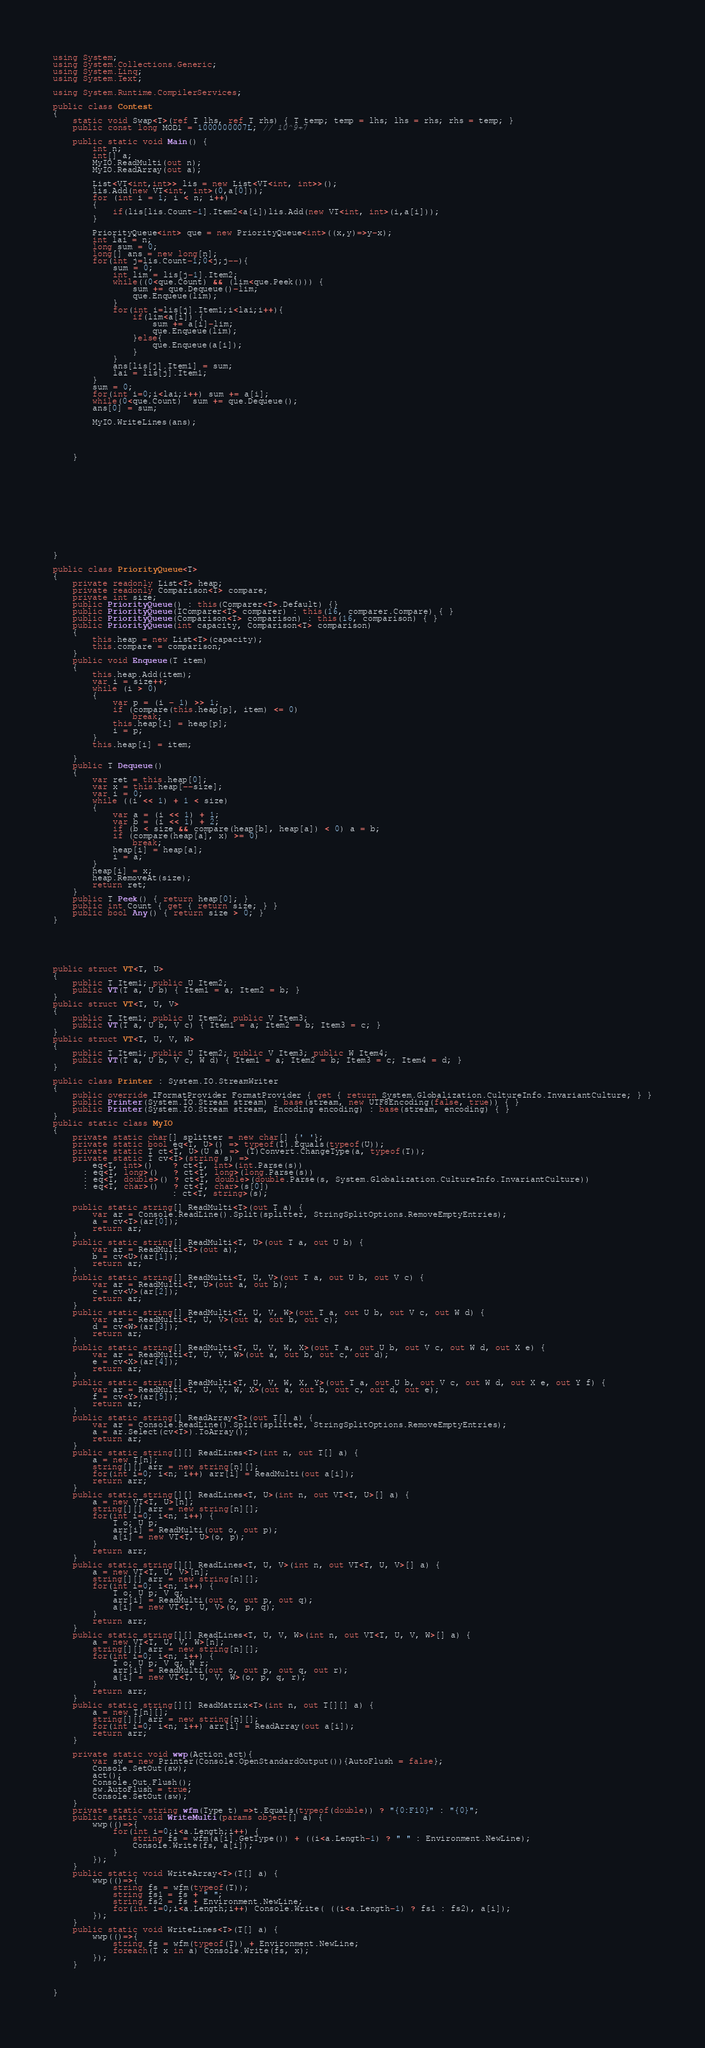<code> <loc_0><loc_0><loc_500><loc_500><_C#_>using System;
using System.Collections.Generic;
using System.Linq;
using System.Text;

using System.Runtime.CompilerServices;

public class Contest
{
	static void Swap<T>(ref T lhs, ref T rhs) { T temp; temp = lhs; lhs = rhs; rhs = temp; }
	public const long MOD1 = 1000000007L; // 10^9+7

	public static void Main() {
        int n;
		int[] a;
		MyIO.ReadMulti(out n);
		MyIO.ReadArray(out a);

		List<VT<int,int>> lis = new List<VT<int, int>>();
		lis.Add(new VT<int, int>(0,a[0]));
		for (int i = 1; i < n; i++)
		{
			if(lis[lis.Count-1].Item2<a[i])lis.Add(new VT<int, int>(i,a[i]));
		}

		PriorityQueue<int> que = new PriorityQueue<int>((x,y)=>y-x);
		int lai = n;
		long sum = 0;
		long[] ans = new long[n];
		for(int j=lis.Count-1;0<j;j--){
			sum = 0;
			int lim = lis[j-1].Item2;
			while((0<que.Count) && (lim<que.Peek())) {
				sum += que.Dequeue()-lim;
				que.Enqueue(lim);
			}
			for(int i=lis[j].Item1;i<lai;i++){
				if(lim<a[i]) { 
					sum += a[i]-lim;
					que.Enqueue(lim);
				}else{
					que.Enqueue(a[i]);	
				}
			}
			ans[lis[j].Item1] = sum;
			lai = lis[j].Item1;
		}
		sum = 0;
		for(int i=0;i<lai;i++) sum += a[i];
		while(0<que.Count)  sum += que.Dequeue();
		ans[0] = sum;

		MyIO.WriteLines(ans);
 
 
 
		
	}

 
 
 







 
 
}
 
public class PriorityQueue<T>
{
    private readonly List<T> heap;
    private readonly Comparison<T> compare;
    private int size;
    public PriorityQueue() : this(Comparer<T>.Default) {} 
    public PriorityQueue(IComparer<T> comparer) : this(16, comparer.Compare) { }
    public PriorityQueue(Comparison<T> comparison) : this(16, comparison) { }
    public PriorityQueue(int capacity, Comparison<T> comparison)
    {
        this.heap = new List<T>(capacity);
        this.compare = comparison;
    }
    public void Enqueue(T item)
    {
        this.heap.Add(item);
        var i = size++;
        while (i > 0)
        {
            var p = (i - 1) >> 1;
            if (compare(this.heap[p], item) <= 0)
                break;
            this.heap[i] = heap[p];
            i = p;
        }
        this.heap[i] = item;

    }
    public T Dequeue()
    {
        var ret = this.heap[0];
        var x = this.heap[--size];
        var i = 0;
        while ((i << 1) + 1 < size)
        {
            var a = (i << 1) + 1;
            var b = (i << 1) + 2;
            if (b < size && compare(heap[b], heap[a]) < 0) a = b;
            if (compare(heap[a], x) >= 0)
                break;
            heap[i] = heap[a];
            i = a;
        }
        heap[i] = x;
        heap.RemoveAt(size);
        return ret;
    }
    public T Peek() { return heap[0]; }
    public int Count { get { return size; } }
    public bool Any() { return size > 0; }
}






public struct VT<T, U>
{
	public T Item1; public U Item2;
    public VT(T a, U b) { Item1 = a; Item2 = b; }
}
public struct VT<T, U, V>
{
	public T Item1; public U Item2; public V Item3;
    public VT(T a, U b, V c) { Item1 = a; Item2 = b; Item3 = c; }
}
public struct VT<T, U, V, W>
{
	public T Item1; public U Item2; public V Item3; public W Item4;
    public VT(T a, U b, V c, W d) { Item1 = a; Item2 = b; Item3 = c; Item4 = d; }
}

public class Printer : System.IO.StreamWriter
{
	public override IFormatProvider FormatProvider { get { return System.Globalization.CultureInfo.InvariantCulture; } }
	public Printer(System.IO.Stream stream) : base(stream, new UTF8Encoding(false, true)) { }
	public Printer(System.IO.Stream stream, Encoding encoding) : base(stream, encoding) { }
}
public static class MyIO
{
	private static char[] splitter = new char[] {' '};
	private static bool eq<T, U>() => typeof(T).Equals(typeof(U));
	private static T ct<T, U>(U a) => (T)Convert.ChangeType(a, typeof(T));
	private static T cv<T>(string s) =>
		eq<T, int>()    ? ct<T, int>(int.Parse(s))
	  : eq<T, long>()   ? ct<T, long>(long.Parse(s))
	  : eq<T, double>() ? ct<T, double>(double.Parse(s, System.Globalization.CultureInfo.InvariantCulture))
	  : eq<T, char>()   ? ct<T, char>(s[0])
						: ct<T, string>(s);
			
	public static string[] ReadMulti<T>(out T a) {
		var ar = Console.ReadLine().Split(splitter, StringSplitOptions.RemoveEmptyEntries); 
		a = cv<T>(ar[0]);
		return ar;
	}
	public static string[] ReadMulti<T, U>(out T a, out U b) {
		var ar = ReadMulti<T>(out a); 
        b = cv<U>(ar[1]);
		return ar;
	}
	public static string[] ReadMulti<T, U, V>(out T a, out U b, out V c) {
		var ar = ReadMulti<T, U>(out a, out b); 
        c = cv<V>(ar[2]);
		return ar;
	}
	public static string[] ReadMulti<T, U, V, W>(out T a, out U b, out V c, out W d) {
		var ar = ReadMulti<T, U, V>(out a, out b, out c); 
        d = cv<W>(ar[3]);
		return ar;
	}
	public static string[] ReadMulti<T, U, V, W, X>(out T a, out U b, out V c, out W d, out X e) {
		var ar = ReadMulti<T, U, V, W>(out a, out b, out c, out d); 
        e = cv<X>(ar[4]);
		return ar;
	}
	public static string[] ReadMulti<T, U, V, W, X, Y>(out T a, out U b, out V c, out W d, out X e, out Y f) {
		var ar = ReadMulti<T, U, V, W, X>(out a, out b, out c, out d, out e); 
        f = cv<Y>(ar[5]);
		return ar;
	}
	public static string[] ReadArray<T>(out T[] a) {		
		var ar = Console.ReadLine().Split(splitter, StringSplitOptions.RemoveEmptyEntries);
		a = ar.Select(cv<T>).ToArray();
		return ar;
	}		
	public static string[][] ReadLines<T>(int n, out T[] a) {
		a = new T[n];
		string[][] arr = new string[n][];
		for(int i=0; i<n; i++) arr[i] = ReadMulti(out a[i]);
		return arr;
	}
	public static string[][] ReadLines<T, U>(int n, out VT<T, U>[] a) {
		a = new VT<T, U>[n];
		string[][] arr = new string[n][];
		for(int i=0; i<n; i++) {
			T o; U p;
			arr[i] = ReadMulti(out o, out p);
			a[i] = new VT<T, U>(o, p);
		}
		return arr;
	}
	public static string[][] ReadLines<T, U, V>(int n, out VT<T, U, V>[] a) {
		a = new VT<T, U, V>[n];
		string[][] arr = new string[n][];
		for(int i=0; i<n; i++) {
			T o; U p; V q;
			arr[i] = ReadMulti(out o, out p, out q);
			a[i] = new VT<T, U, V>(o, p, q);
		}
		return arr;
	}
	public static string[][] ReadLines<T, U, V, W>(int n, out VT<T, U, V, W>[] a) {
		a = new VT<T, U, V, W>[n];
		string[][] arr = new string[n][];
		for(int i=0; i<n; i++) {
			T o; U p; V q; W r;
			arr[i] = ReadMulti(out o, out p, out q, out r);
			a[i] = new VT<T, U, V, W>(o, p, q, r);
		}
		return arr;
	}
	public static string[][] ReadMatrix<T>(int n, out T[][] a) {
		a = new T[n][];
		string[][] arr = new string[n][];
		for(int i=0; i<n; i++) arr[i] = ReadArray(out a[i]);
		return arr;
	}

	private static void wwp(Action act){
		var sw = new Printer(Console.OpenStandardOutput()){AutoFlush = false};
		Console.SetOut(sw);
		act();
		Console.Out.Flush();
		sw.AutoFlush = true;
		Console.SetOut(sw);
	}
	private static string wfm(Type t) =>t.Equals(typeof(double)) ? "{0:F10}" : "{0}";
	public static void WriteMulti(params object[] a) {
		wwp(()=>{
			for(int i=0;i<a.Length;i++) {
				string fs = wfm(a[i].GetType()) + ((i<a.Length-1) ? " " : Environment.NewLine);
				Console.Write(fs, a[i]);
			}
		});
	}
	public static void WriteArray<T>(T[] a) {
		wwp(()=>{
			string fs = wfm(typeof(T));
			string fs1 = fs + " ";
			string fs2 = fs + Environment.NewLine;
			for(int i=0;i<a.Length;i++) Console.Write( ((i<a.Length-1) ? fs1 : fs2), a[i]);
		});
	}
	public static void WriteLines<T>(T[] a) {
		wwp(()=>{
			string fs = wfm(typeof(T)) + Environment.NewLine;
			foreach(T x in a) Console.Write(fs, x);
		});
	}



}



</code> 